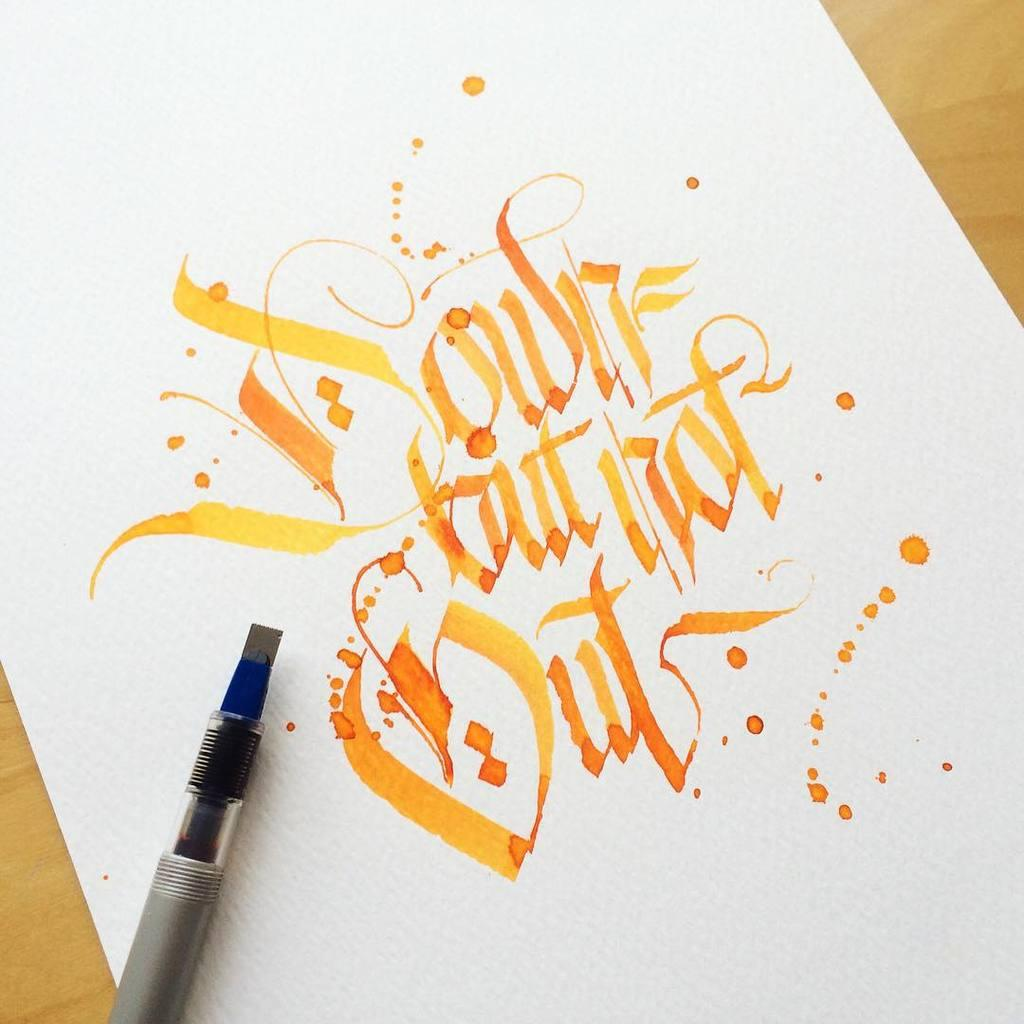What is present on the paper in the image? There is text on the paper in the image. Where is the pen located in the image? The pen is at the left bottom of the image. What type of surface is visible at the bottom of the image? There is a wooden surface at the bottom of the image. Can you tell me what time it is on the watch in the image? There is no watch present in the image. How many seeds are visible on the paper in the image? There are no seeds visible on the paper in the image. 